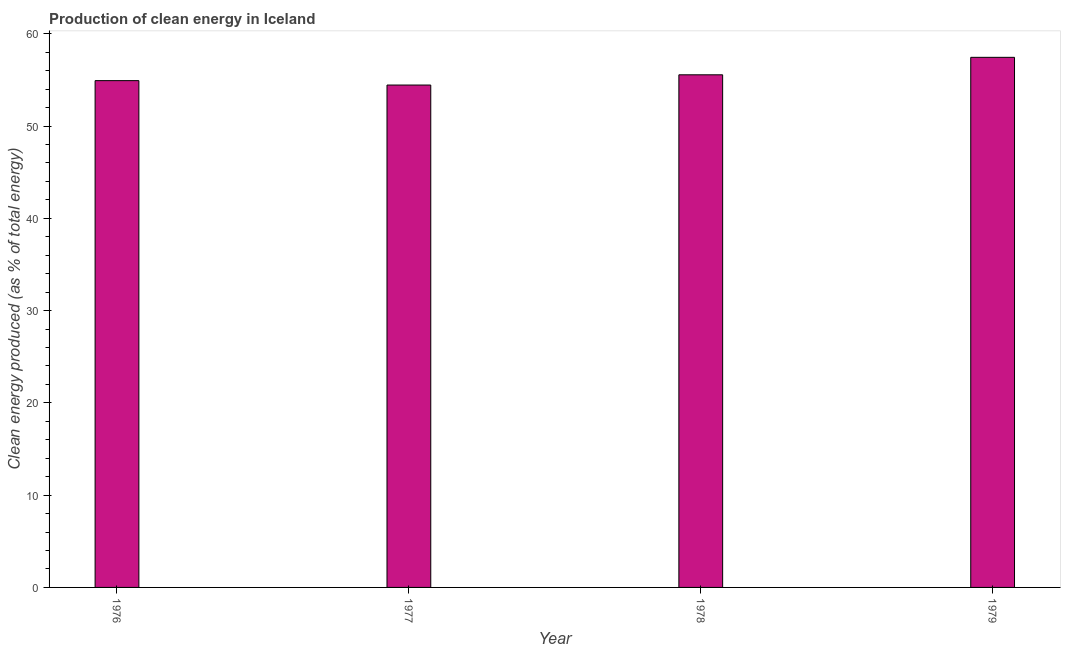Does the graph contain any zero values?
Provide a short and direct response. No. What is the title of the graph?
Make the answer very short. Production of clean energy in Iceland. What is the label or title of the X-axis?
Ensure brevity in your answer.  Year. What is the label or title of the Y-axis?
Provide a succinct answer. Clean energy produced (as % of total energy). What is the production of clean energy in 1979?
Your answer should be compact. 57.45. Across all years, what is the maximum production of clean energy?
Make the answer very short. 57.45. Across all years, what is the minimum production of clean energy?
Make the answer very short. 54.45. In which year was the production of clean energy maximum?
Provide a short and direct response. 1979. What is the sum of the production of clean energy?
Offer a very short reply. 222.37. What is the difference between the production of clean energy in 1976 and 1977?
Offer a terse response. 0.48. What is the average production of clean energy per year?
Make the answer very short. 55.59. What is the median production of clean energy?
Keep it short and to the point. 55.24. What is the ratio of the production of clean energy in 1977 to that in 1978?
Offer a very short reply. 0.98. Is the difference between the production of clean energy in 1977 and 1978 greater than the difference between any two years?
Your response must be concise. No. What is the difference between the highest and the second highest production of clean energy?
Offer a very short reply. 1.9. Are all the bars in the graph horizontal?
Make the answer very short. No. What is the Clean energy produced (as % of total energy) of 1976?
Keep it short and to the point. 54.92. What is the Clean energy produced (as % of total energy) of 1977?
Provide a succinct answer. 54.45. What is the Clean energy produced (as % of total energy) of 1978?
Your response must be concise. 55.55. What is the Clean energy produced (as % of total energy) of 1979?
Your answer should be compact. 57.45. What is the difference between the Clean energy produced (as % of total energy) in 1976 and 1977?
Make the answer very short. 0.48. What is the difference between the Clean energy produced (as % of total energy) in 1976 and 1978?
Offer a terse response. -0.63. What is the difference between the Clean energy produced (as % of total energy) in 1976 and 1979?
Your answer should be very brief. -2.53. What is the difference between the Clean energy produced (as % of total energy) in 1977 and 1978?
Your response must be concise. -1.11. What is the difference between the Clean energy produced (as % of total energy) in 1977 and 1979?
Your answer should be compact. -3. What is the difference between the Clean energy produced (as % of total energy) in 1978 and 1979?
Give a very brief answer. -1.89. What is the ratio of the Clean energy produced (as % of total energy) in 1976 to that in 1977?
Ensure brevity in your answer.  1.01. What is the ratio of the Clean energy produced (as % of total energy) in 1976 to that in 1979?
Your response must be concise. 0.96. What is the ratio of the Clean energy produced (as % of total energy) in 1977 to that in 1978?
Offer a terse response. 0.98. What is the ratio of the Clean energy produced (as % of total energy) in 1977 to that in 1979?
Give a very brief answer. 0.95. 